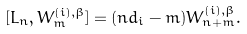Convert formula to latex. <formula><loc_0><loc_0><loc_500><loc_500>[ L _ { n } , W ^ { ( i ) , \beta } _ { m } ] = ( n d _ { i } - m ) W ^ { ( i ) , \beta } _ { n + m } .</formula> 